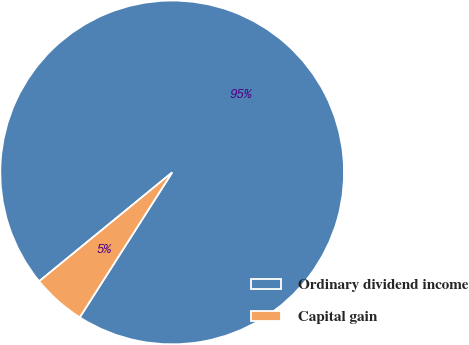Convert chart to OTSL. <chart><loc_0><loc_0><loc_500><loc_500><pie_chart><fcel>Ordinary dividend income<fcel>Capital gain<nl><fcel>94.95%<fcel>5.05%<nl></chart> 